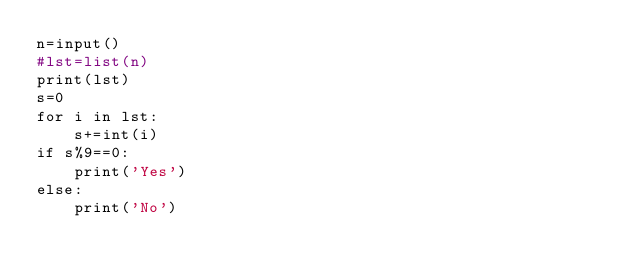Convert code to text. <code><loc_0><loc_0><loc_500><loc_500><_Python_>n=input()
#lst=list(n)
print(lst)
s=0
for i in lst:
    s+=int(i)
if s%9==0:
    print('Yes')
else:
    print('No')</code> 